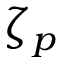Convert formula to latex. <formula><loc_0><loc_0><loc_500><loc_500>\zeta _ { p }</formula> 